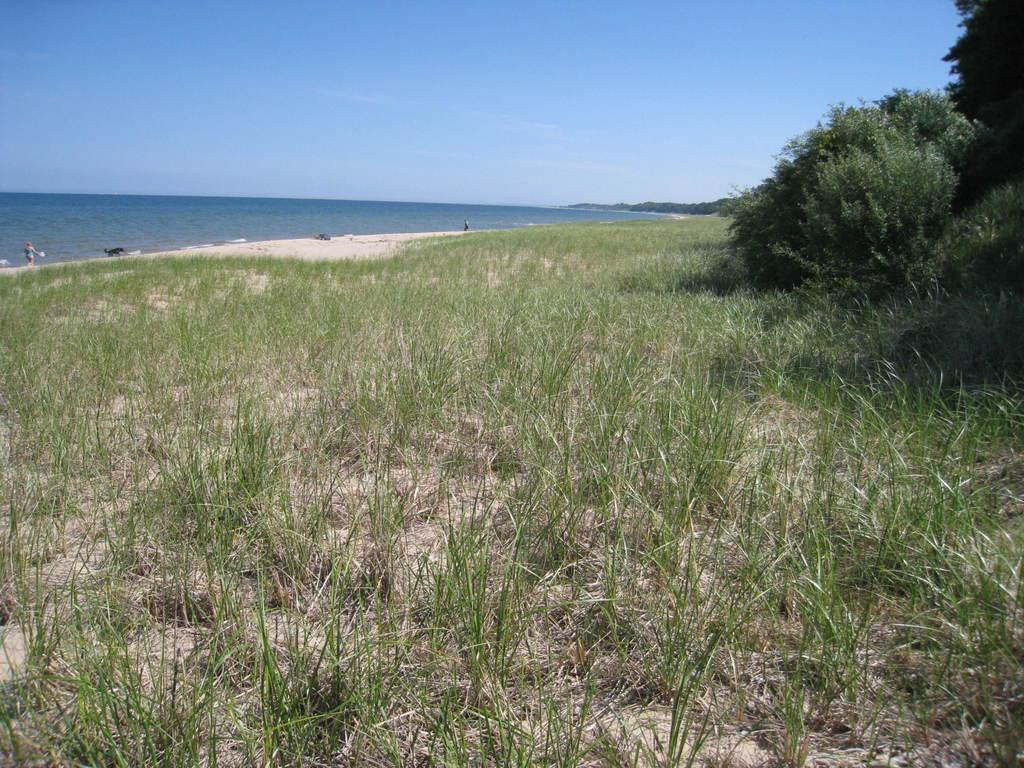How would you summarize this image in a sentence or two? In the image there is a land covered with a lot of grass, on the right side there are few trees and in the background there is a water surface. 